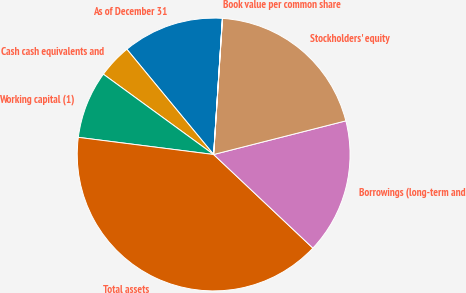Convert chart. <chart><loc_0><loc_0><loc_500><loc_500><pie_chart><fcel>As of December 31<fcel>Cash cash equivalents and<fcel>Working capital (1)<fcel>Total assets<fcel>Borrowings (long-term and<fcel>Stockholders' equity<fcel>Book value per common share<nl><fcel>12.0%<fcel>4.01%<fcel>8.01%<fcel>39.98%<fcel>16.0%<fcel>20.0%<fcel>0.01%<nl></chart> 